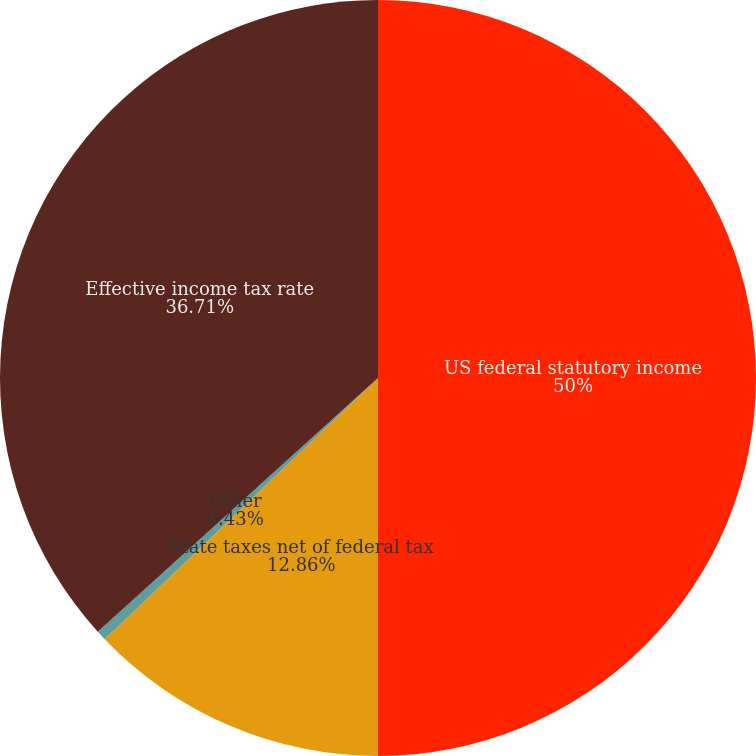<chart> <loc_0><loc_0><loc_500><loc_500><pie_chart><fcel>US federal statutory income<fcel>State taxes net of federal tax<fcel>Other<fcel>Effective income tax rate<nl><fcel>50.0%<fcel>12.86%<fcel>0.43%<fcel>36.71%<nl></chart> 